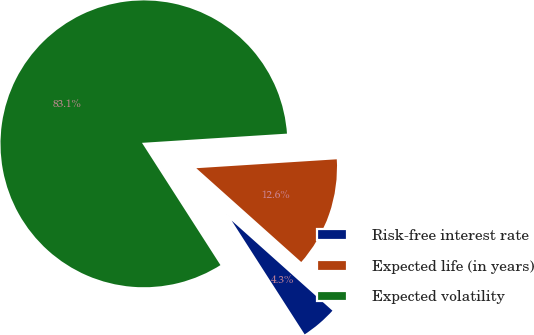Convert chart. <chart><loc_0><loc_0><loc_500><loc_500><pie_chart><fcel>Risk-free interest rate<fcel>Expected life (in years)<fcel>Expected volatility<nl><fcel>4.31%<fcel>12.62%<fcel>83.08%<nl></chart> 